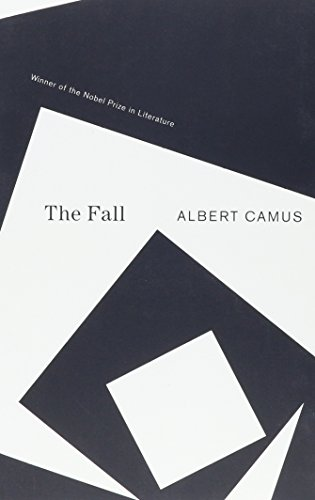Who wrote this book? The book 'The Fall' was written by Albert Camus, an influential French philosopher and writer known for his existential themes. 